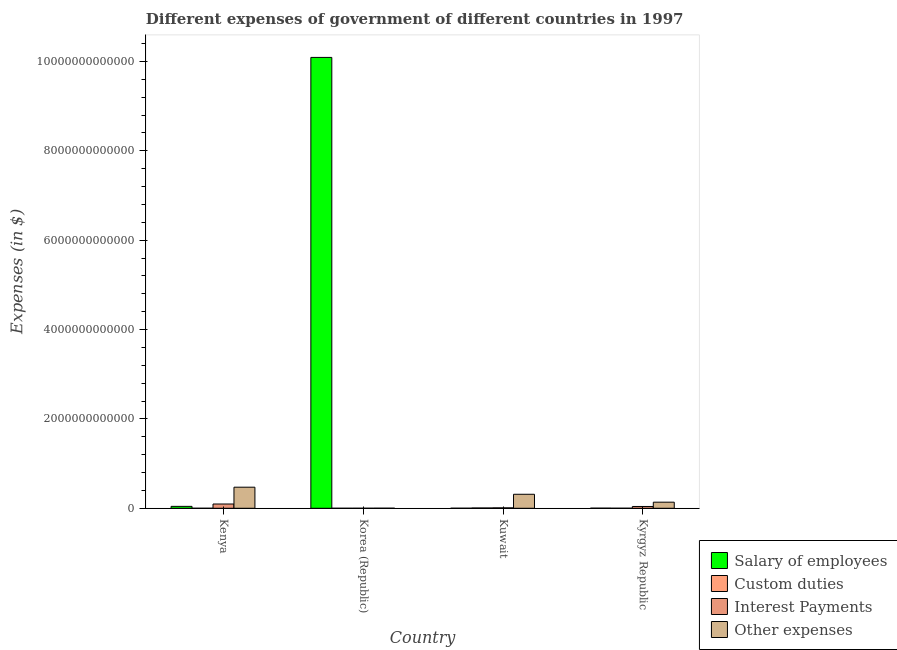How many groups of bars are there?
Your answer should be compact. 4. Are the number of bars per tick equal to the number of legend labels?
Your response must be concise. Yes. What is the label of the 3rd group of bars from the left?
Make the answer very short. Kuwait. What is the amount spent on interest payments in Kenya?
Provide a succinct answer. 9.54e+1. Across all countries, what is the maximum amount spent on salary of employees?
Your answer should be compact. 1.01e+13. Across all countries, what is the minimum amount spent on custom duties?
Your response must be concise. 2.20e+07. In which country was the amount spent on custom duties maximum?
Provide a succinct answer. Kuwait. In which country was the amount spent on salary of employees minimum?
Provide a short and direct response. Kuwait. What is the total amount spent on other expenses in the graph?
Offer a very short reply. 9.23e+11. What is the difference between the amount spent on salary of employees in Kuwait and that in Kyrgyz Republic?
Provide a succinct answer. -1.12e+09. What is the difference between the amount spent on salary of employees in Kyrgyz Republic and the amount spent on interest payments in Kuwait?
Give a very brief answer. -7.10e+09. What is the average amount spent on other expenses per country?
Provide a short and direct response. 2.31e+11. What is the difference between the amount spent on custom duties and amount spent on salary of employees in Kyrgyz Republic?
Provide a short and direct response. -1.64e+09. In how many countries, is the amount spent on salary of employees greater than 5200000000000 $?
Offer a very short reply. 1. What is the ratio of the amount spent on interest payments in Korea (Republic) to that in Kyrgyz Republic?
Provide a succinct answer. 0.01. What is the difference between the highest and the second highest amount spent on custom duties?
Keep it short and to the point. 5.97e+09. What is the difference between the highest and the lowest amount spent on other expenses?
Your answer should be compact. 4.70e+11. In how many countries, is the amount spent on other expenses greater than the average amount spent on other expenses taken over all countries?
Give a very brief answer. 2. Is the sum of the amount spent on custom duties in Kenya and Kyrgyz Republic greater than the maximum amount spent on salary of employees across all countries?
Provide a short and direct response. No. Is it the case that in every country, the sum of the amount spent on other expenses and amount spent on salary of employees is greater than the sum of amount spent on custom duties and amount spent on interest payments?
Your answer should be compact. No. What does the 1st bar from the left in Kenya represents?
Give a very brief answer. Salary of employees. What does the 2nd bar from the right in Korea (Republic) represents?
Give a very brief answer. Interest Payments. How many countries are there in the graph?
Your response must be concise. 4. What is the difference between two consecutive major ticks on the Y-axis?
Ensure brevity in your answer.  2.00e+12. Does the graph contain any zero values?
Ensure brevity in your answer.  No. Where does the legend appear in the graph?
Give a very brief answer. Bottom right. How many legend labels are there?
Give a very brief answer. 4. What is the title of the graph?
Your answer should be compact. Different expenses of government of different countries in 1997. Does "Others" appear as one of the legend labels in the graph?
Your answer should be compact. No. What is the label or title of the Y-axis?
Give a very brief answer. Expenses (in $). What is the Expenses (in $) in Salary of employees in Kenya?
Provide a succinct answer. 4.26e+1. What is the Expenses (in $) in Custom duties in Kenya?
Your response must be concise. 8.30e+07. What is the Expenses (in $) of Interest Payments in Kenya?
Give a very brief answer. 9.54e+1. What is the Expenses (in $) in Other expenses in Kenya?
Keep it short and to the point. 4.72e+11. What is the Expenses (in $) in Salary of employees in Korea (Republic)?
Provide a short and direct response. 1.01e+13. What is the Expenses (in $) of Custom duties in Korea (Republic)?
Ensure brevity in your answer.  2.20e+07. What is the Expenses (in $) in Interest Payments in Korea (Republic)?
Your response must be concise. 2.01e+08. What is the Expenses (in $) of Other expenses in Korea (Republic)?
Keep it short and to the point. 1.46e+09. What is the Expenses (in $) of Salary of employees in Kuwait?
Your response must be concise. 1.08e+09. What is the Expenses (in $) of Custom duties in Kuwait?
Offer a terse response. 6.52e+09. What is the Expenses (in $) of Interest Payments in Kuwait?
Your response must be concise. 9.30e+09. What is the Expenses (in $) of Other expenses in Kuwait?
Your answer should be very brief. 3.13e+11. What is the Expenses (in $) in Salary of employees in Kyrgyz Republic?
Offer a very short reply. 2.20e+09. What is the Expenses (in $) in Custom duties in Kyrgyz Republic?
Provide a succinct answer. 5.53e+08. What is the Expenses (in $) of Interest Payments in Kyrgyz Republic?
Ensure brevity in your answer.  4.00e+1. What is the Expenses (in $) of Other expenses in Kyrgyz Republic?
Your answer should be compact. 1.36e+11. Across all countries, what is the maximum Expenses (in $) of Salary of employees?
Provide a succinct answer. 1.01e+13. Across all countries, what is the maximum Expenses (in $) in Custom duties?
Ensure brevity in your answer.  6.52e+09. Across all countries, what is the maximum Expenses (in $) in Interest Payments?
Provide a succinct answer. 9.54e+1. Across all countries, what is the maximum Expenses (in $) in Other expenses?
Provide a short and direct response. 4.72e+11. Across all countries, what is the minimum Expenses (in $) in Salary of employees?
Your response must be concise. 1.08e+09. Across all countries, what is the minimum Expenses (in $) in Custom duties?
Ensure brevity in your answer.  2.20e+07. Across all countries, what is the minimum Expenses (in $) of Interest Payments?
Offer a very short reply. 2.01e+08. Across all countries, what is the minimum Expenses (in $) of Other expenses?
Make the answer very short. 1.46e+09. What is the total Expenses (in $) of Salary of employees in the graph?
Offer a very short reply. 1.01e+13. What is the total Expenses (in $) of Custom duties in the graph?
Make the answer very short. 7.18e+09. What is the total Expenses (in $) of Interest Payments in the graph?
Ensure brevity in your answer.  1.45e+11. What is the total Expenses (in $) of Other expenses in the graph?
Offer a very short reply. 9.23e+11. What is the difference between the Expenses (in $) of Salary of employees in Kenya and that in Korea (Republic)?
Your answer should be very brief. -1.00e+13. What is the difference between the Expenses (in $) of Custom duties in Kenya and that in Korea (Republic)?
Keep it short and to the point. 6.10e+07. What is the difference between the Expenses (in $) in Interest Payments in Kenya and that in Korea (Republic)?
Give a very brief answer. 9.52e+1. What is the difference between the Expenses (in $) of Other expenses in Kenya and that in Korea (Republic)?
Your answer should be very brief. 4.70e+11. What is the difference between the Expenses (in $) in Salary of employees in Kenya and that in Kuwait?
Your response must be concise. 4.15e+1. What is the difference between the Expenses (in $) in Custom duties in Kenya and that in Kuwait?
Offer a very short reply. -6.44e+09. What is the difference between the Expenses (in $) in Interest Payments in Kenya and that in Kuwait?
Make the answer very short. 8.61e+1. What is the difference between the Expenses (in $) in Other expenses in Kenya and that in Kuwait?
Offer a very short reply. 1.58e+11. What is the difference between the Expenses (in $) of Salary of employees in Kenya and that in Kyrgyz Republic?
Give a very brief answer. 4.04e+1. What is the difference between the Expenses (in $) in Custom duties in Kenya and that in Kyrgyz Republic?
Give a very brief answer. -4.70e+08. What is the difference between the Expenses (in $) in Interest Payments in Kenya and that in Kyrgyz Republic?
Provide a short and direct response. 5.54e+1. What is the difference between the Expenses (in $) in Other expenses in Kenya and that in Kyrgyz Republic?
Make the answer very short. 3.35e+11. What is the difference between the Expenses (in $) of Salary of employees in Korea (Republic) and that in Kuwait?
Provide a short and direct response. 1.01e+13. What is the difference between the Expenses (in $) of Custom duties in Korea (Republic) and that in Kuwait?
Your answer should be very brief. -6.50e+09. What is the difference between the Expenses (in $) in Interest Payments in Korea (Republic) and that in Kuwait?
Your answer should be compact. -9.10e+09. What is the difference between the Expenses (in $) of Other expenses in Korea (Republic) and that in Kuwait?
Keep it short and to the point. -3.12e+11. What is the difference between the Expenses (in $) in Salary of employees in Korea (Republic) and that in Kyrgyz Republic?
Your answer should be compact. 1.01e+13. What is the difference between the Expenses (in $) of Custom duties in Korea (Republic) and that in Kyrgyz Republic?
Your response must be concise. -5.31e+08. What is the difference between the Expenses (in $) of Interest Payments in Korea (Republic) and that in Kyrgyz Republic?
Keep it short and to the point. -3.98e+1. What is the difference between the Expenses (in $) of Other expenses in Korea (Republic) and that in Kyrgyz Republic?
Give a very brief answer. -1.35e+11. What is the difference between the Expenses (in $) in Salary of employees in Kuwait and that in Kyrgyz Republic?
Your response must be concise. -1.12e+09. What is the difference between the Expenses (in $) of Custom duties in Kuwait and that in Kyrgyz Republic?
Keep it short and to the point. 5.97e+09. What is the difference between the Expenses (in $) of Interest Payments in Kuwait and that in Kyrgyz Republic?
Offer a terse response. -3.07e+1. What is the difference between the Expenses (in $) in Other expenses in Kuwait and that in Kyrgyz Republic?
Offer a terse response. 1.77e+11. What is the difference between the Expenses (in $) in Salary of employees in Kenya and the Expenses (in $) in Custom duties in Korea (Republic)?
Make the answer very short. 4.25e+1. What is the difference between the Expenses (in $) in Salary of employees in Kenya and the Expenses (in $) in Interest Payments in Korea (Republic)?
Keep it short and to the point. 4.24e+1. What is the difference between the Expenses (in $) in Salary of employees in Kenya and the Expenses (in $) in Other expenses in Korea (Republic)?
Your answer should be compact. 4.11e+1. What is the difference between the Expenses (in $) of Custom duties in Kenya and the Expenses (in $) of Interest Payments in Korea (Republic)?
Provide a succinct answer. -1.18e+08. What is the difference between the Expenses (in $) in Custom duties in Kenya and the Expenses (in $) in Other expenses in Korea (Republic)?
Offer a terse response. -1.38e+09. What is the difference between the Expenses (in $) in Interest Payments in Kenya and the Expenses (in $) in Other expenses in Korea (Republic)?
Keep it short and to the point. 9.39e+1. What is the difference between the Expenses (in $) in Salary of employees in Kenya and the Expenses (in $) in Custom duties in Kuwait?
Your answer should be very brief. 3.60e+1. What is the difference between the Expenses (in $) in Salary of employees in Kenya and the Expenses (in $) in Interest Payments in Kuwait?
Your answer should be very brief. 3.33e+1. What is the difference between the Expenses (in $) of Salary of employees in Kenya and the Expenses (in $) of Other expenses in Kuwait?
Offer a very short reply. -2.71e+11. What is the difference between the Expenses (in $) in Custom duties in Kenya and the Expenses (in $) in Interest Payments in Kuwait?
Give a very brief answer. -9.22e+09. What is the difference between the Expenses (in $) of Custom duties in Kenya and the Expenses (in $) of Other expenses in Kuwait?
Offer a very short reply. -3.13e+11. What is the difference between the Expenses (in $) in Interest Payments in Kenya and the Expenses (in $) in Other expenses in Kuwait?
Offer a terse response. -2.18e+11. What is the difference between the Expenses (in $) in Salary of employees in Kenya and the Expenses (in $) in Custom duties in Kyrgyz Republic?
Make the answer very short. 4.20e+1. What is the difference between the Expenses (in $) of Salary of employees in Kenya and the Expenses (in $) of Interest Payments in Kyrgyz Republic?
Provide a succinct answer. 2.58e+09. What is the difference between the Expenses (in $) of Salary of employees in Kenya and the Expenses (in $) of Other expenses in Kyrgyz Republic?
Offer a terse response. -9.39e+1. What is the difference between the Expenses (in $) of Custom duties in Kenya and the Expenses (in $) of Interest Payments in Kyrgyz Republic?
Keep it short and to the point. -3.99e+1. What is the difference between the Expenses (in $) in Custom duties in Kenya and the Expenses (in $) in Other expenses in Kyrgyz Republic?
Give a very brief answer. -1.36e+11. What is the difference between the Expenses (in $) of Interest Payments in Kenya and the Expenses (in $) of Other expenses in Kyrgyz Republic?
Your answer should be very brief. -4.11e+1. What is the difference between the Expenses (in $) of Salary of employees in Korea (Republic) and the Expenses (in $) of Custom duties in Kuwait?
Make the answer very short. 1.01e+13. What is the difference between the Expenses (in $) in Salary of employees in Korea (Republic) and the Expenses (in $) in Interest Payments in Kuwait?
Make the answer very short. 1.01e+13. What is the difference between the Expenses (in $) of Salary of employees in Korea (Republic) and the Expenses (in $) of Other expenses in Kuwait?
Make the answer very short. 9.78e+12. What is the difference between the Expenses (in $) in Custom duties in Korea (Republic) and the Expenses (in $) in Interest Payments in Kuwait?
Offer a very short reply. -9.28e+09. What is the difference between the Expenses (in $) of Custom duties in Korea (Republic) and the Expenses (in $) of Other expenses in Kuwait?
Your answer should be very brief. -3.13e+11. What is the difference between the Expenses (in $) of Interest Payments in Korea (Republic) and the Expenses (in $) of Other expenses in Kuwait?
Provide a succinct answer. -3.13e+11. What is the difference between the Expenses (in $) in Salary of employees in Korea (Republic) and the Expenses (in $) in Custom duties in Kyrgyz Republic?
Give a very brief answer. 1.01e+13. What is the difference between the Expenses (in $) of Salary of employees in Korea (Republic) and the Expenses (in $) of Interest Payments in Kyrgyz Republic?
Give a very brief answer. 1.01e+13. What is the difference between the Expenses (in $) of Salary of employees in Korea (Republic) and the Expenses (in $) of Other expenses in Kyrgyz Republic?
Make the answer very short. 9.95e+12. What is the difference between the Expenses (in $) of Custom duties in Korea (Republic) and the Expenses (in $) of Interest Payments in Kyrgyz Republic?
Offer a terse response. -4.00e+1. What is the difference between the Expenses (in $) in Custom duties in Korea (Republic) and the Expenses (in $) in Other expenses in Kyrgyz Republic?
Offer a terse response. -1.36e+11. What is the difference between the Expenses (in $) of Interest Payments in Korea (Republic) and the Expenses (in $) of Other expenses in Kyrgyz Republic?
Offer a very short reply. -1.36e+11. What is the difference between the Expenses (in $) in Salary of employees in Kuwait and the Expenses (in $) in Custom duties in Kyrgyz Republic?
Give a very brief answer. 5.22e+08. What is the difference between the Expenses (in $) in Salary of employees in Kuwait and the Expenses (in $) in Interest Payments in Kyrgyz Republic?
Offer a very short reply. -3.89e+1. What is the difference between the Expenses (in $) in Salary of employees in Kuwait and the Expenses (in $) in Other expenses in Kyrgyz Republic?
Offer a terse response. -1.35e+11. What is the difference between the Expenses (in $) of Custom duties in Kuwait and the Expenses (in $) of Interest Payments in Kyrgyz Republic?
Your answer should be very brief. -3.35e+1. What is the difference between the Expenses (in $) of Custom duties in Kuwait and the Expenses (in $) of Other expenses in Kyrgyz Republic?
Your answer should be compact. -1.30e+11. What is the difference between the Expenses (in $) in Interest Payments in Kuwait and the Expenses (in $) in Other expenses in Kyrgyz Republic?
Your answer should be very brief. -1.27e+11. What is the average Expenses (in $) of Salary of employees per country?
Your response must be concise. 2.53e+12. What is the average Expenses (in $) in Custom duties per country?
Offer a terse response. 1.80e+09. What is the average Expenses (in $) in Interest Payments per country?
Your response must be concise. 3.62e+1. What is the average Expenses (in $) of Other expenses per country?
Ensure brevity in your answer.  2.31e+11. What is the difference between the Expenses (in $) in Salary of employees and Expenses (in $) in Custom duties in Kenya?
Provide a short and direct response. 4.25e+1. What is the difference between the Expenses (in $) in Salary of employees and Expenses (in $) in Interest Payments in Kenya?
Ensure brevity in your answer.  -5.28e+1. What is the difference between the Expenses (in $) of Salary of employees and Expenses (in $) of Other expenses in Kenya?
Keep it short and to the point. -4.29e+11. What is the difference between the Expenses (in $) in Custom duties and Expenses (in $) in Interest Payments in Kenya?
Ensure brevity in your answer.  -9.53e+1. What is the difference between the Expenses (in $) in Custom duties and Expenses (in $) in Other expenses in Kenya?
Your answer should be compact. -4.71e+11. What is the difference between the Expenses (in $) of Interest Payments and Expenses (in $) of Other expenses in Kenya?
Offer a terse response. -3.76e+11. What is the difference between the Expenses (in $) of Salary of employees and Expenses (in $) of Custom duties in Korea (Republic)?
Offer a very short reply. 1.01e+13. What is the difference between the Expenses (in $) of Salary of employees and Expenses (in $) of Interest Payments in Korea (Republic)?
Offer a very short reply. 1.01e+13. What is the difference between the Expenses (in $) in Salary of employees and Expenses (in $) in Other expenses in Korea (Republic)?
Your answer should be very brief. 1.01e+13. What is the difference between the Expenses (in $) in Custom duties and Expenses (in $) in Interest Payments in Korea (Republic)?
Offer a very short reply. -1.79e+08. What is the difference between the Expenses (in $) in Custom duties and Expenses (in $) in Other expenses in Korea (Republic)?
Provide a short and direct response. -1.44e+09. What is the difference between the Expenses (in $) in Interest Payments and Expenses (in $) in Other expenses in Korea (Republic)?
Offer a terse response. -1.26e+09. What is the difference between the Expenses (in $) of Salary of employees and Expenses (in $) of Custom duties in Kuwait?
Give a very brief answer. -5.45e+09. What is the difference between the Expenses (in $) in Salary of employees and Expenses (in $) in Interest Payments in Kuwait?
Ensure brevity in your answer.  -8.22e+09. What is the difference between the Expenses (in $) in Salary of employees and Expenses (in $) in Other expenses in Kuwait?
Your answer should be compact. -3.12e+11. What is the difference between the Expenses (in $) in Custom duties and Expenses (in $) in Interest Payments in Kuwait?
Provide a succinct answer. -2.78e+09. What is the difference between the Expenses (in $) in Custom duties and Expenses (in $) in Other expenses in Kuwait?
Provide a succinct answer. -3.07e+11. What is the difference between the Expenses (in $) of Interest Payments and Expenses (in $) of Other expenses in Kuwait?
Your answer should be compact. -3.04e+11. What is the difference between the Expenses (in $) of Salary of employees and Expenses (in $) of Custom duties in Kyrgyz Republic?
Make the answer very short. 1.64e+09. What is the difference between the Expenses (in $) of Salary of employees and Expenses (in $) of Interest Payments in Kyrgyz Republic?
Ensure brevity in your answer.  -3.78e+1. What is the difference between the Expenses (in $) in Salary of employees and Expenses (in $) in Other expenses in Kyrgyz Republic?
Your answer should be very brief. -1.34e+11. What is the difference between the Expenses (in $) in Custom duties and Expenses (in $) in Interest Payments in Kyrgyz Republic?
Give a very brief answer. -3.94e+1. What is the difference between the Expenses (in $) of Custom duties and Expenses (in $) of Other expenses in Kyrgyz Republic?
Make the answer very short. -1.36e+11. What is the difference between the Expenses (in $) of Interest Payments and Expenses (in $) of Other expenses in Kyrgyz Republic?
Offer a terse response. -9.65e+1. What is the ratio of the Expenses (in $) of Salary of employees in Kenya to that in Korea (Republic)?
Provide a succinct answer. 0. What is the ratio of the Expenses (in $) of Custom duties in Kenya to that in Korea (Republic)?
Give a very brief answer. 3.77. What is the ratio of the Expenses (in $) of Interest Payments in Kenya to that in Korea (Republic)?
Ensure brevity in your answer.  474.72. What is the ratio of the Expenses (in $) in Other expenses in Kenya to that in Korea (Republic)?
Ensure brevity in your answer.  323. What is the ratio of the Expenses (in $) of Salary of employees in Kenya to that in Kuwait?
Offer a very short reply. 39.6. What is the ratio of the Expenses (in $) in Custom duties in Kenya to that in Kuwait?
Offer a very short reply. 0.01. What is the ratio of the Expenses (in $) in Interest Payments in Kenya to that in Kuwait?
Provide a short and direct response. 10.25. What is the ratio of the Expenses (in $) in Other expenses in Kenya to that in Kuwait?
Keep it short and to the point. 1.5. What is the ratio of the Expenses (in $) in Salary of employees in Kenya to that in Kyrgyz Republic?
Your response must be concise. 19.38. What is the ratio of the Expenses (in $) of Custom duties in Kenya to that in Kyrgyz Republic?
Your answer should be very brief. 0.15. What is the ratio of the Expenses (in $) in Interest Payments in Kenya to that in Kyrgyz Republic?
Give a very brief answer. 2.38. What is the ratio of the Expenses (in $) in Other expenses in Kenya to that in Kyrgyz Republic?
Your response must be concise. 3.46. What is the ratio of the Expenses (in $) of Salary of employees in Korea (Republic) to that in Kuwait?
Make the answer very short. 9386.98. What is the ratio of the Expenses (in $) of Custom duties in Korea (Republic) to that in Kuwait?
Offer a very short reply. 0. What is the ratio of the Expenses (in $) in Interest Payments in Korea (Republic) to that in Kuwait?
Your answer should be very brief. 0.02. What is the ratio of the Expenses (in $) in Other expenses in Korea (Republic) to that in Kuwait?
Provide a succinct answer. 0. What is the ratio of the Expenses (in $) of Salary of employees in Korea (Republic) to that in Kyrgyz Republic?
Your response must be concise. 4593.92. What is the ratio of the Expenses (in $) in Custom duties in Korea (Republic) to that in Kyrgyz Republic?
Give a very brief answer. 0.04. What is the ratio of the Expenses (in $) in Interest Payments in Korea (Republic) to that in Kyrgyz Republic?
Offer a very short reply. 0.01. What is the ratio of the Expenses (in $) in Other expenses in Korea (Republic) to that in Kyrgyz Republic?
Your answer should be very brief. 0.01. What is the ratio of the Expenses (in $) of Salary of employees in Kuwait to that in Kyrgyz Republic?
Give a very brief answer. 0.49. What is the ratio of the Expenses (in $) of Custom duties in Kuwait to that in Kyrgyz Republic?
Give a very brief answer. 11.8. What is the ratio of the Expenses (in $) of Interest Payments in Kuwait to that in Kyrgyz Republic?
Make the answer very short. 0.23. What is the ratio of the Expenses (in $) of Other expenses in Kuwait to that in Kyrgyz Republic?
Offer a terse response. 2.3. What is the difference between the highest and the second highest Expenses (in $) in Salary of employees?
Offer a terse response. 1.00e+13. What is the difference between the highest and the second highest Expenses (in $) in Custom duties?
Provide a short and direct response. 5.97e+09. What is the difference between the highest and the second highest Expenses (in $) in Interest Payments?
Provide a succinct answer. 5.54e+1. What is the difference between the highest and the second highest Expenses (in $) of Other expenses?
Make the answer very short. 1.58e+11. What is the difference between the highest and the lowest Expenses (in $) of Salary of employees?
Your answer should be very brief. 1.01e+13. What is the difference between the highest and the lowest Expenses (in $) in Custom duties?
Make the answer very short. 6.50e+09. What is the difference between the highest and the lowest Expenses (in $) of Interest Payments?
Make the answer very short. 9.52e+1. What is the difference between the highest and the lowest Expenses (in $) of Other expenses?
Ensure brevity in your answer.  4.70e+11. 